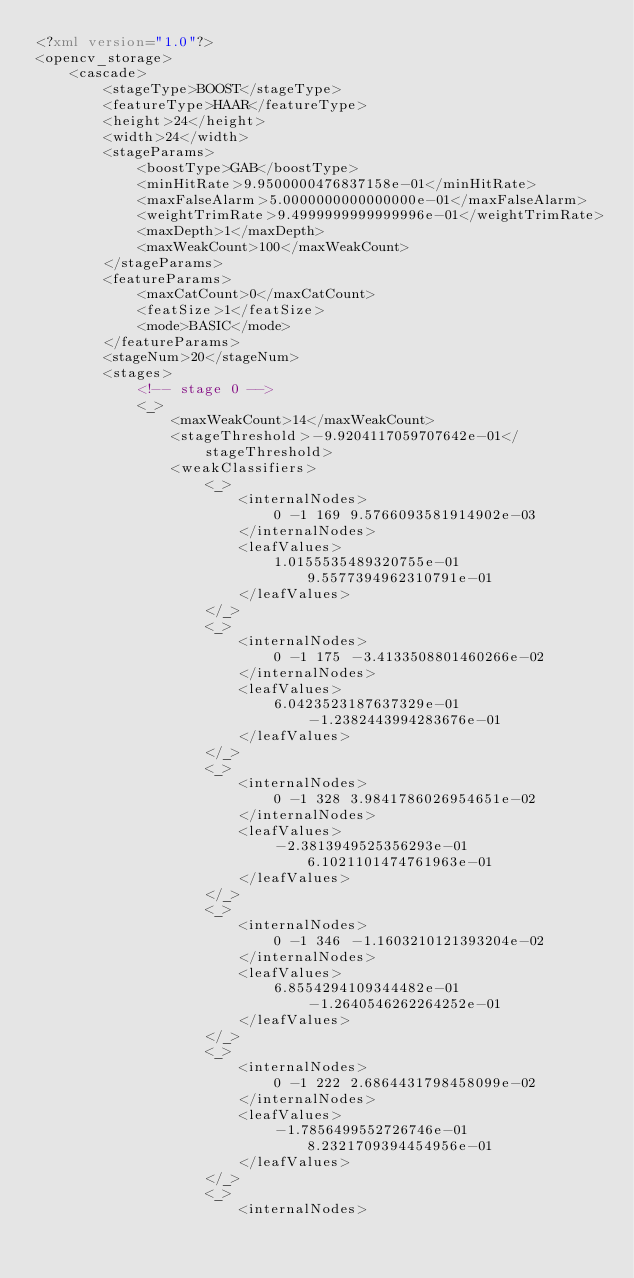<code> <loc_0><loc_0><loc_500><loc_500><_XML_><?xml version="1.0"?>
<opencv_storage>
    <cascade>
        <stageType>BOOST</stageType>
        <featureType>HAAR</featureType>
        <height>24</height>
        <width>24</width>
        <stageParams>
            <boostType>GAB</boostType>
            <minHitRate>9.9500000476837158e-01</minHitRate>
            <maxFalseAlarm>5.0000000000000000e-01</maxFalseAlarm>
            <weightTrimRate>9.4999999999999996e-01</weightTrimRate>
            <maxDepth>1</maxDepth>
            <maxWeakCount>100</maxWeakCount>
        </stageParams>
        <featureParams>
            <maxCatCount>0</maxCatCount>
            <featSize>1</featSize>
            <mode>BASIC</mode>
        </featureParams>
        <stageNum>20</stageNum>
        <stages>
            <!-- stage 0 -->
            <_>
                <maxWeakCount>14</maxWeakCount>
                <stageThreshold>-9.9204117059707642e-01</stageThreshold>
                <weakClassifiers>
                    <_>
                        <internalNodes>
                            0 -1 169 9.5766093581914902e-03
                        </internalNodes>
                        <leafValues>
                            1.0155535489320755e-01 9.5577394962310791e-01
                        </leafValues>
                    </_>
                    <_>
                        <internalNodes>
                            0 -1 175 -3.4133508801460266e-02
                        </internalNodes>
                        <leafValues>
                            6.0423523187637329e-01 -1.2382443994283676e-01
                        </leafValues>
                    </_>
                    <_>
                        <internalNodes>
                            0 -1 328 3.9841786026954651e-02
                        </internalNodes>
                        <leafValues>
                            -2.3813949525356293e-01 6.1021101474761963e-01
                        </leafValues>
                    </_>
                    <_>
                        <internalNodes>
                            0 -1 346 -1.1603210121393204e-02
                        </internalNodes>
                        <leafValues>
                            6.8554294109344482e-01 -1.2640546262264252e-01
                        </leafValues>
                    </_>
                    <_>
                        <internalNodes>
                            0 -1 222 2.6864431798458099e-02
                        </internalNodes>
                        <leafValues>
                            -1.7856499552726746e-01 8.2321709394454956e-01
                        </leafValues>
                    </_>
                    <_>
                        <internalNodes></code> 